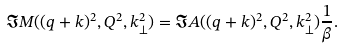Convert formula to latex. <formula><loc_0><loc_0><loc_500><loc_500>\Im M ( ( q + k ) ^ { 2 } , Q ^ { 2 } , k ^ { 2 } _ { \perp } ) = \Im A ( ( q + k ) ^ { 2 } , Q ^ { 2 } , k ^ { 2 } _ { \perp } ) \frac { 1 } { \beta } .</formula> 